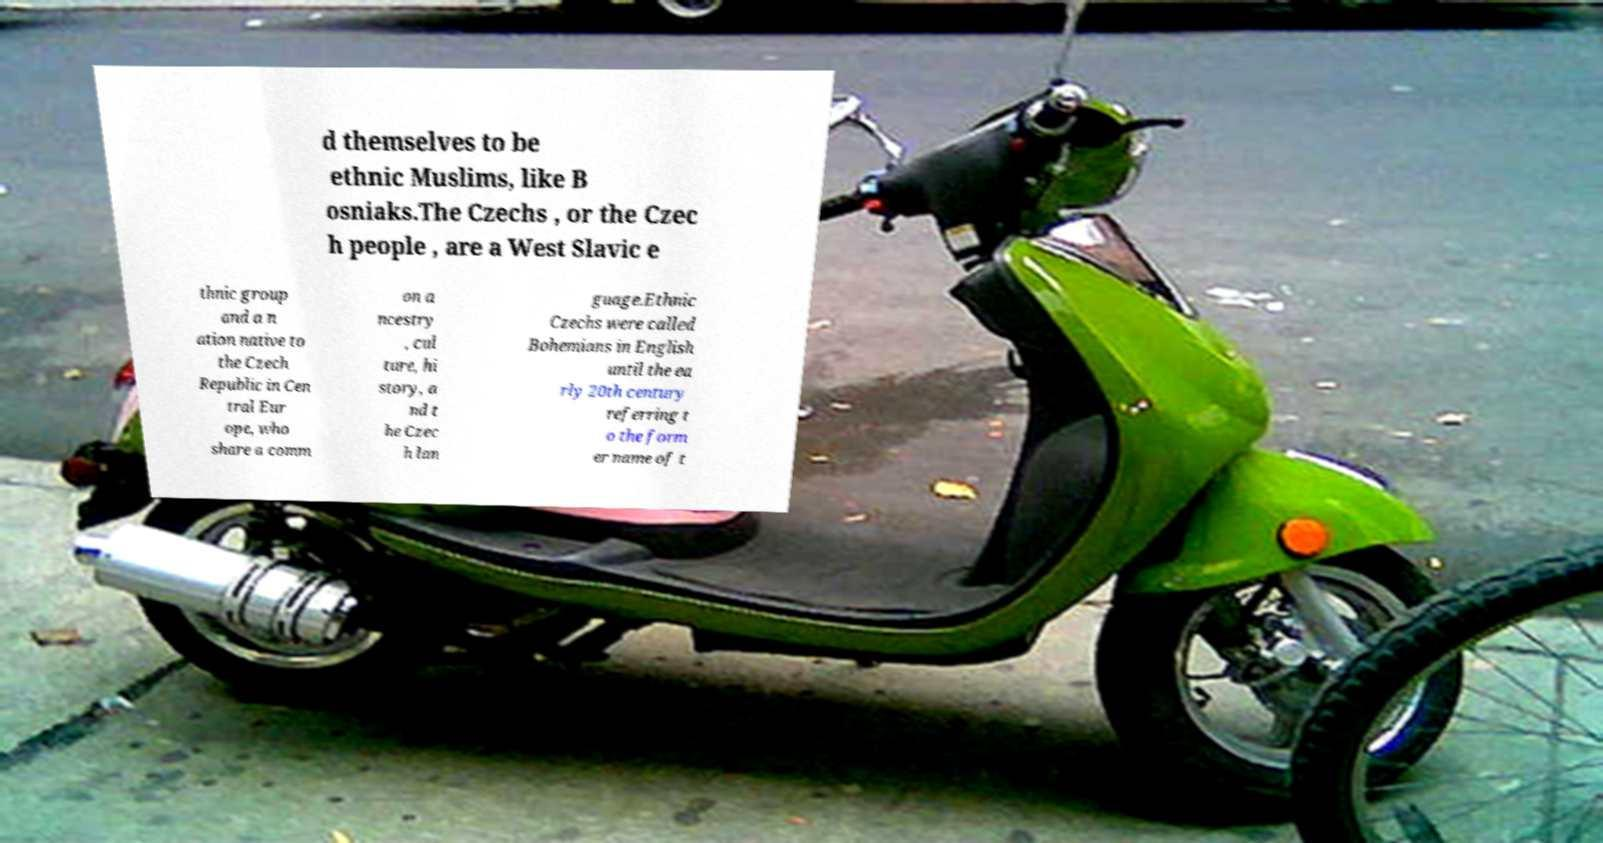For documentation purposes, I need the text within this image transcribed. Could you provide that? d themselves to be ethnic Muslims, like B osniaks.The Czechs , or the Czec h people , are a West Slavic e thnic group and a n ation native to the Czech Republic in Cen tral Eur ope, who share a comm on a ncestry , cul ture, hi story, a nd t he Czec h lan guage.Ethnic Czechs were called Bohemians in English until the ea rly 20th century referring t o the form er name of t 